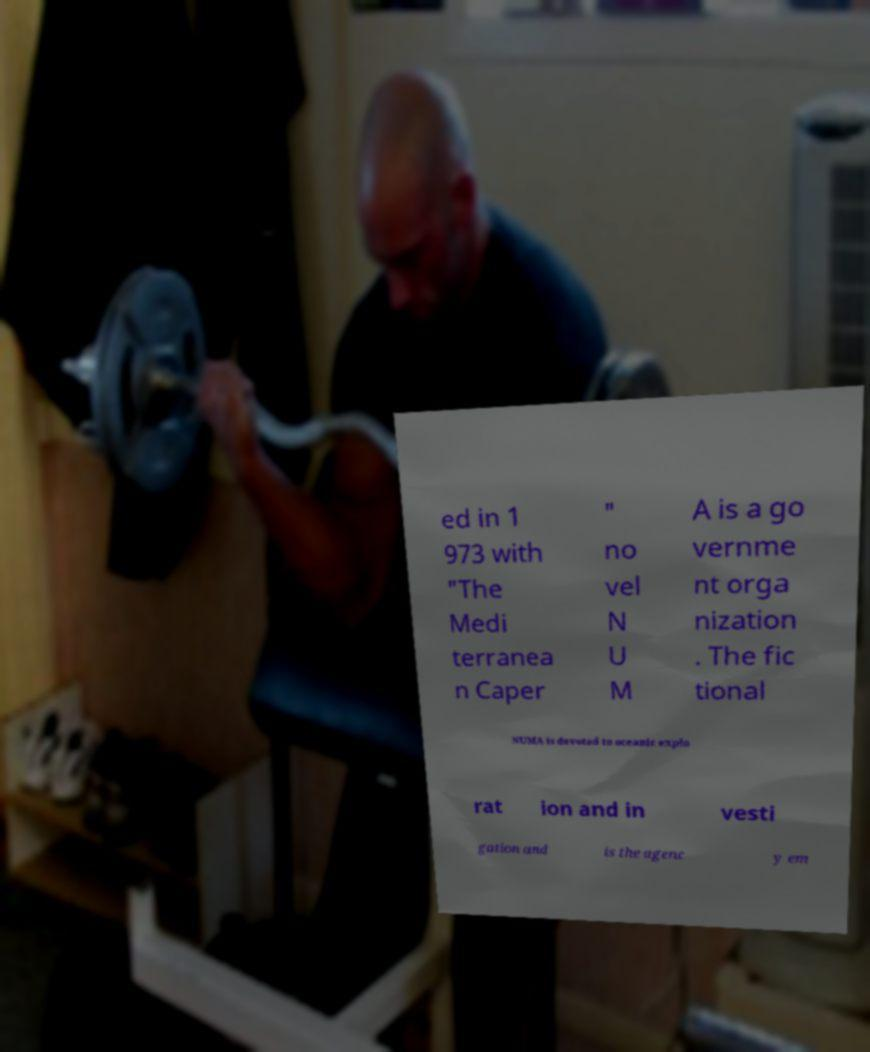What messages or text are displayed in this image? I need them in a readable, typed format. ed in 1 973 with "The Medi terranea n Caper " no vel N U M A is a go vernme nt orga nization . The fic tional NUMA is devoted to oceanic explo rat ion and in vesti gation and is the agenc y em 